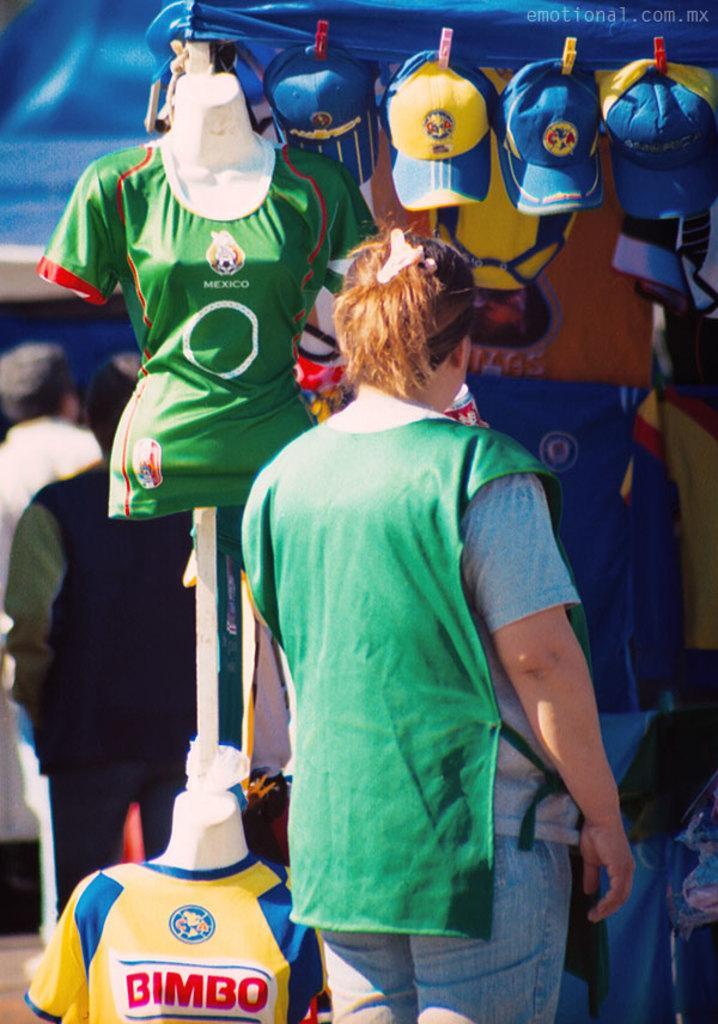Describe this image in one or two sentences. In this picture we can see three people standing, T-shirts, caps and some objects. 